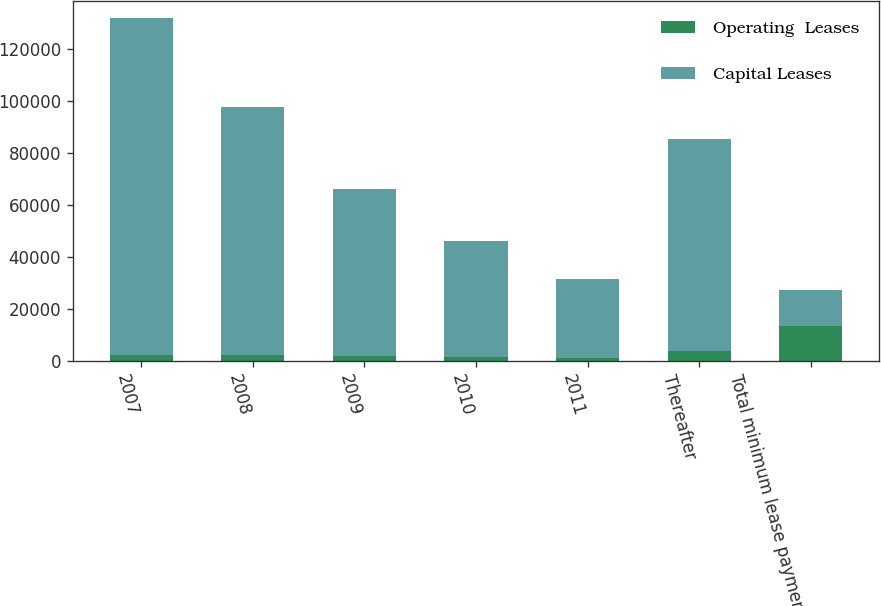Convert chart. <chart><loc_0><loc_0><loc_500><loc_500><stacked_bar_chart><ecel><fcel>2007<fcel>2008<fcel>2009<fcel>2010<fcel>2011<fcel>Thereafter<fcel>Total minimum lease payments<nl><fcel>Operating  Leases<fcel>2509<fcel>2344<fcel>2158<fcel>1760<fcel>1092<fcel>3752<fcel>13615<nl><fcel>Capital Leases<fcel>129156<fcel>95152<fcel>63990<fcel>44239<fcel>30535<fcel>81534<fcel>13615<nl></chart> 